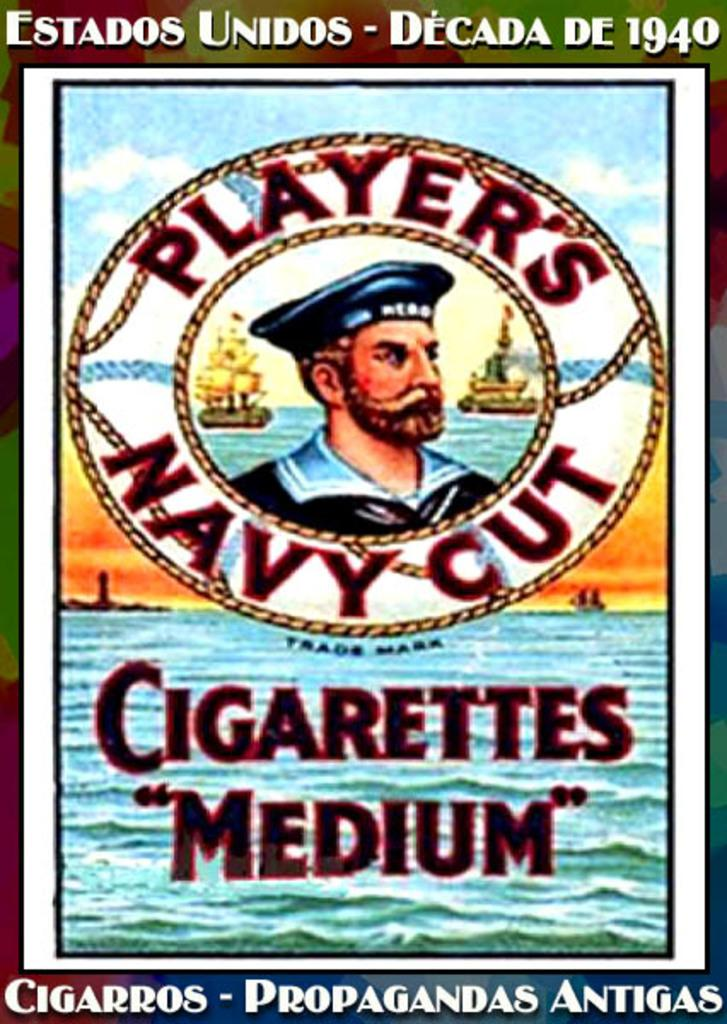What can be observed about the nature of the image? The image is edited. What is the main subject in the center of the image? There is a depiction of a person in the center of the image. Are there any words or phrases present in the image? Yes, there is text in the image. What type of environment or setting is depicted in the image? There is water visible in the image. What type of hope can be seen in the image? There is no reference to hope in the image, so it cannot be determined from the image. --- Facts: 1. There is a person holding a book in the image. 2. The book has a blue cover. 3. The person is sitting on a chair. 4. There is a table next to the chair. 5. The table has a lamp on it. Absurd Topics: elephant, ocean, dance Conversation: What is the person in the image holding? The person in the image is holding a book. What color is the book's cover? The book has a blue cover. What is the person sitting on in the image? The person is sitting on a chair. What object is present on the table next to the chair? There is a lamp on the table. Reasoning: Let's think step by step in order to produce the conversation. We start by identifying the main subject in the image, which is a person holding a book. Then, we describe the book's appearance, including its blue cover. Next, we mention the person's seating arrangement, which is on a chair. Finally, we describe the object on the table next to the chair, which is a lamp. Absurd Question/Answer: Can you see an elephant swimming in the ocean in the image? There is no elephant or ocean present in the image. 